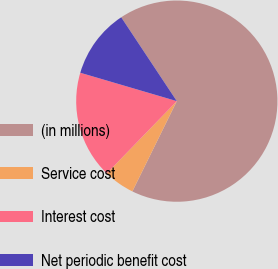Convert chart. <chart><loc_0><loc_0><loc_500><loc_500><pie_chart><fcel>(in millions)<fcel>Service cost<fcel>Interest cost<fcel>Net periodic benefit cost<nl><fcel>66.6%<fcel>4.97%<fcel>17.3%<fcel>11.13%<nl></chart> 